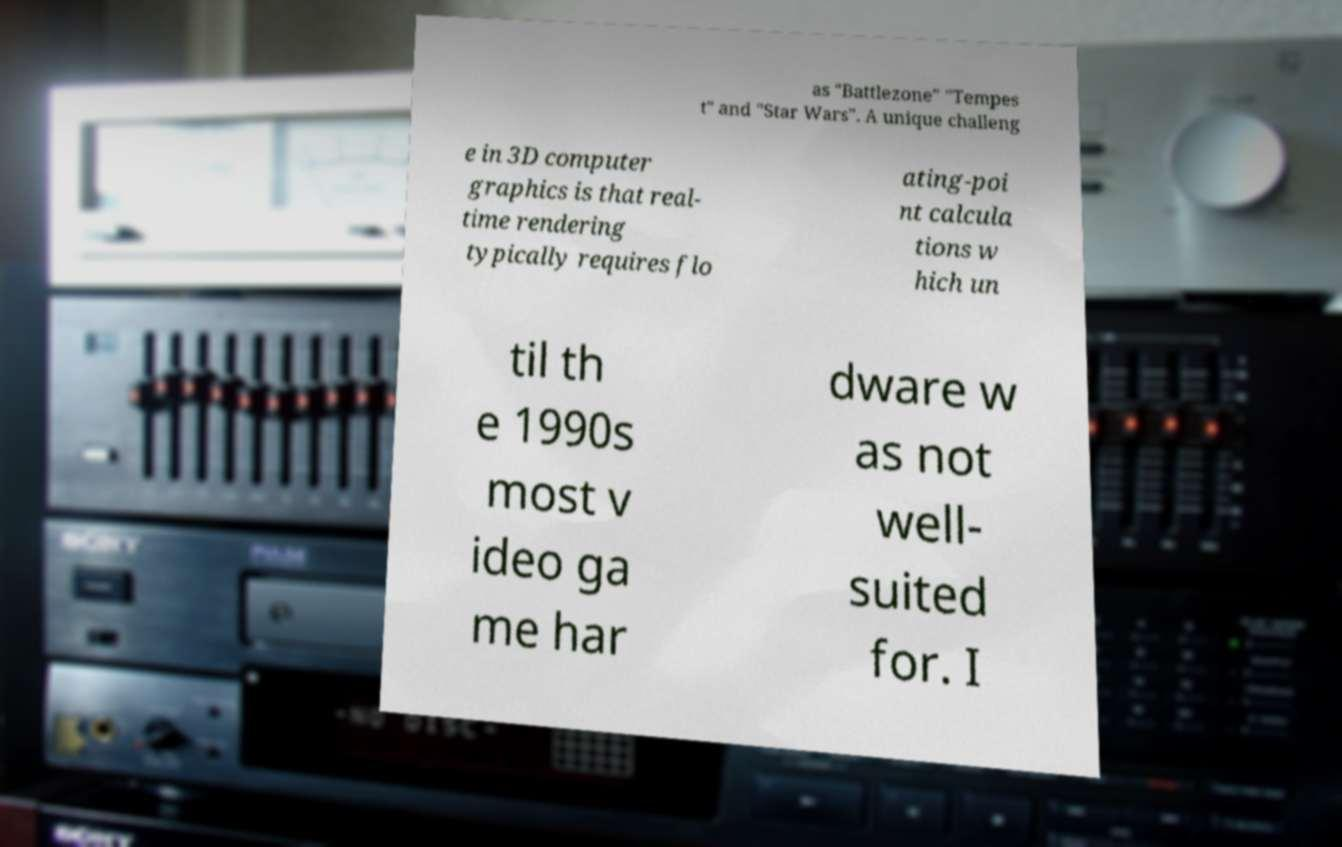I need the written content from this picture converted into text. Can you do that? as "Battlezone" "Tempes t" and "Star Wars". A unique challeng e in 3D computer graphics is that real- time rendering typically requires flo ating-poi nt calcula tions w hich un til th e 1990s most v ideo ga me har dware w as not well- suited for. I 